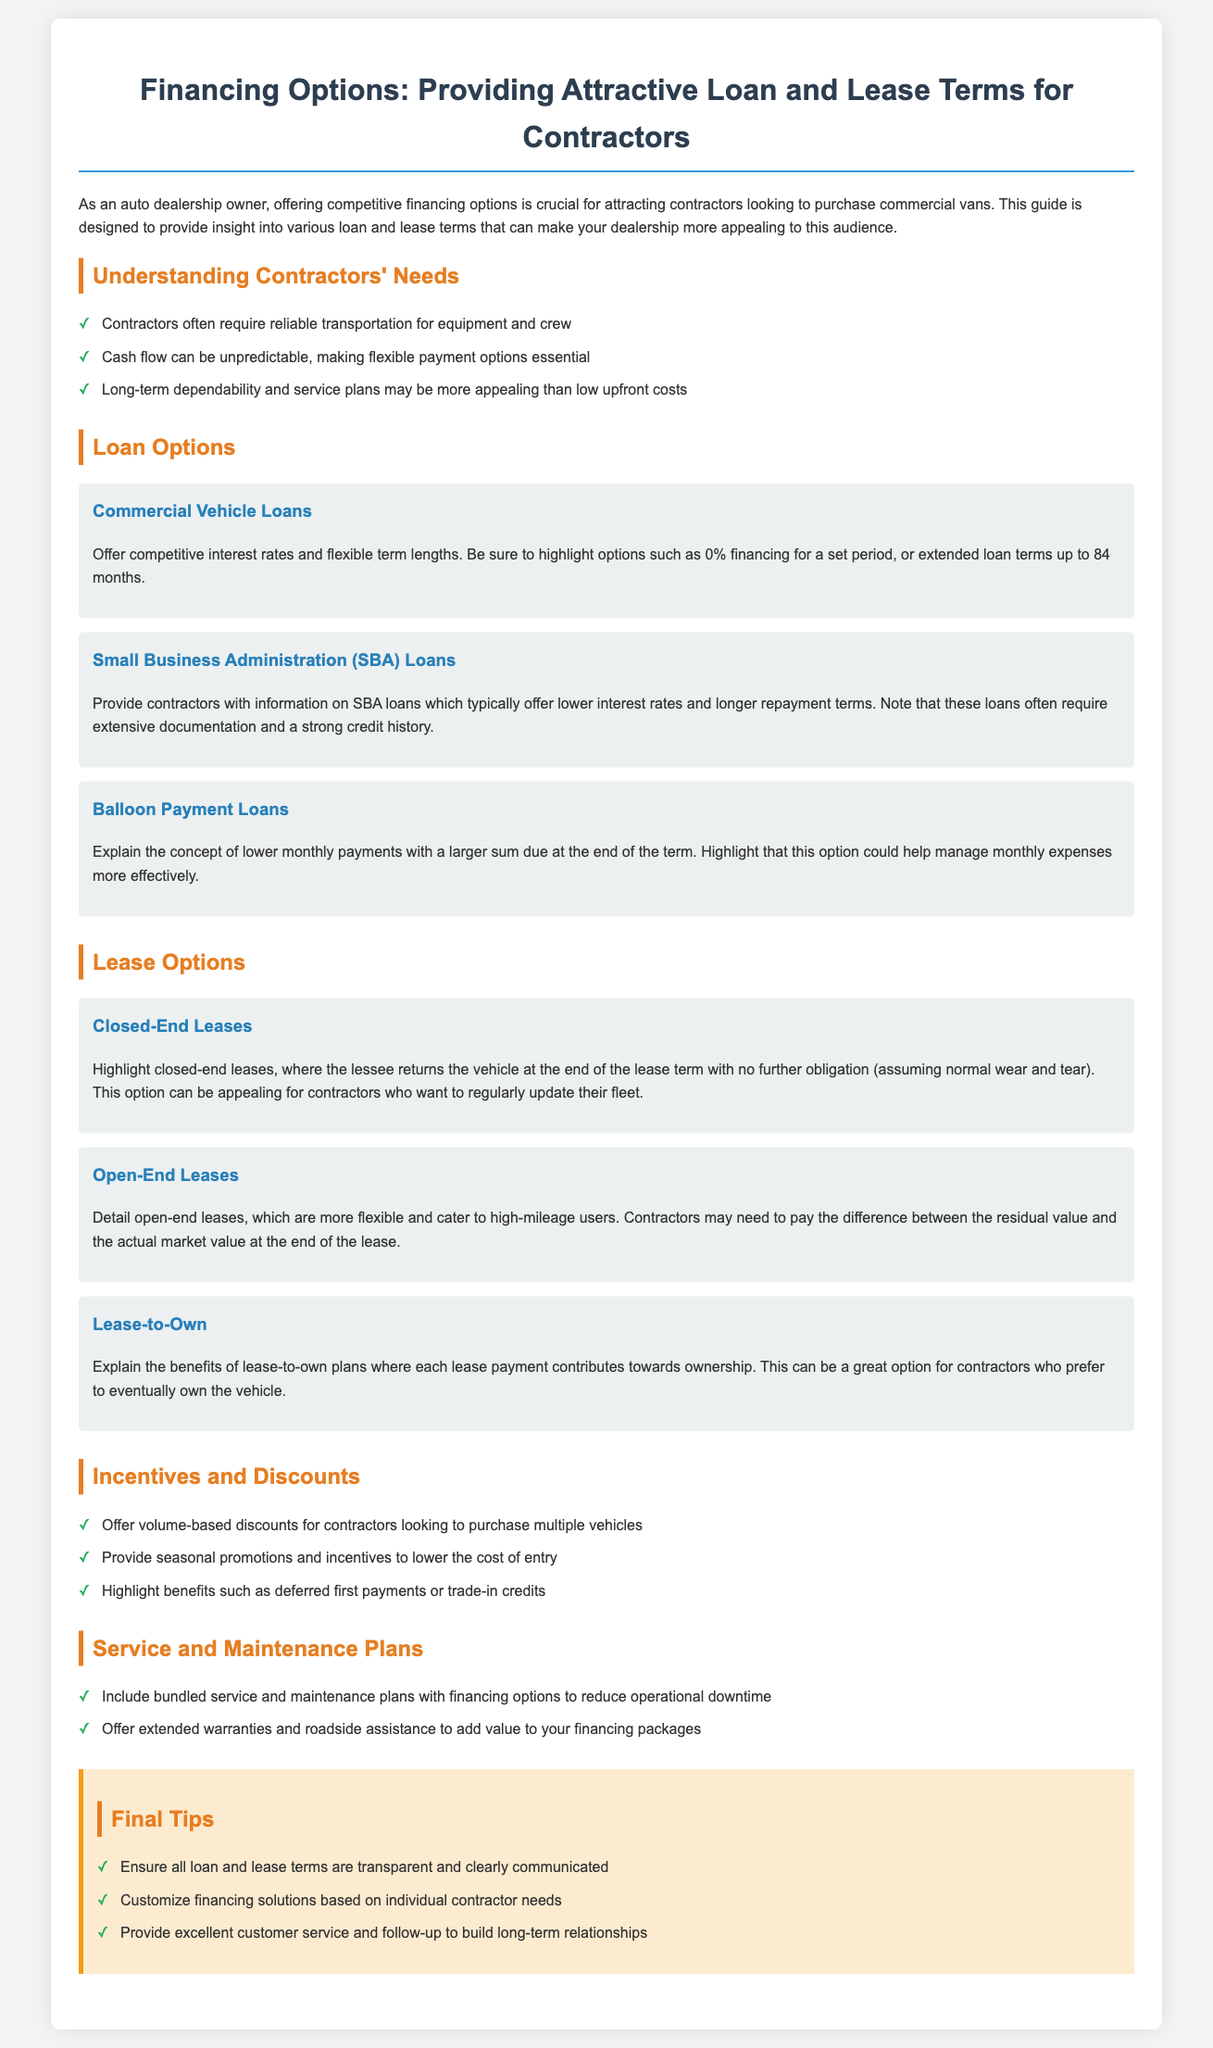What are the three types of loan options mentioned? The document lists three types of loan options: Commercial Vehicle Loans, Small Business Administration (SBA) Loans, and Balloon Payment Loans.
Answer: Commercial Vehicle Loans, SBA Loans, Balloon Payment Loans What is a key need of contractors regarding financing? The document states that cash flow can be unpredictable, making flexible payment options essential for contractors.
Answer: Flexible payment options How long can loan terms be extended up to? The document mentions that loan terms can be extended up to 84 months.
Answer: 84 months What type of lease allows returning the vehicle with no further obligation? The document describes closed-end leases, where the lessee returns the vehicle at the end of the lease term with no further obligation.
Answer: Closed-End Leases What is a benefit of lease-to-own plans? The document states that each lease payment contributes towards ownership, which is a significant benefit of lease-to-own plans.
Answer: Contributes towards ownership What should be included with financing options to reduce operational downtime? The document suggests including bundled service and maintenance plans with financing options to reduce operational downtime.
Answer: Bundled service and maintenance plans What is one of the final tips regarding loan and lease terms? The document advises ensuring all loan and lease terms are transparent and clearly communicated as one of the final tips.
Answer: Transparent and clearly communicated What is a characteristic of open-end leases? The document states that open-end leases are more flexible and cater to high-mileage users.
Answer: More flexible Which loan option typically requires extensive documentation? The document notes that Small Business Administration (SBA) Loans often require extensive documentation.
Answer: SBA Loans 